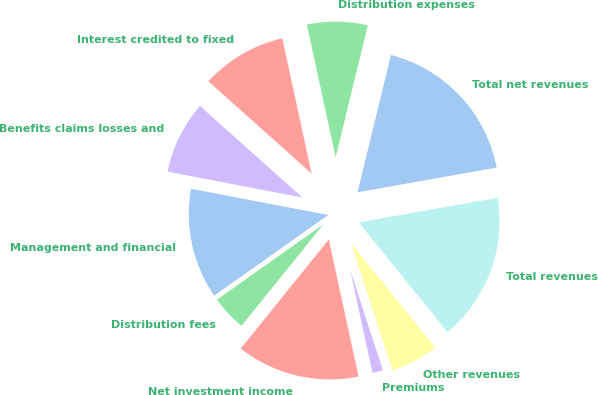Convert chart. <chart><loc_0><loc_0><loc_500><loc_500><pie_chart><fcel>Management and financial<fcel>Distribution fees<fcel>Net investment income<fcel>Premiums<fcel>Other revenues<fcel>Total revenues<fcel>Total net revenues<fcel>Distribution expenses<fcel>Interest credited to fixed<fcel>Benefits claims losses and<nl><fcel>12.8%<fcel>4.4%<fcel>14.2%<fcel>1.61%<fcel>5.8%<fcel>16.99%<fcel>18.39%<fcel>7.2%<fcel>10.0%<fcel>8.6%<nl></chart> 